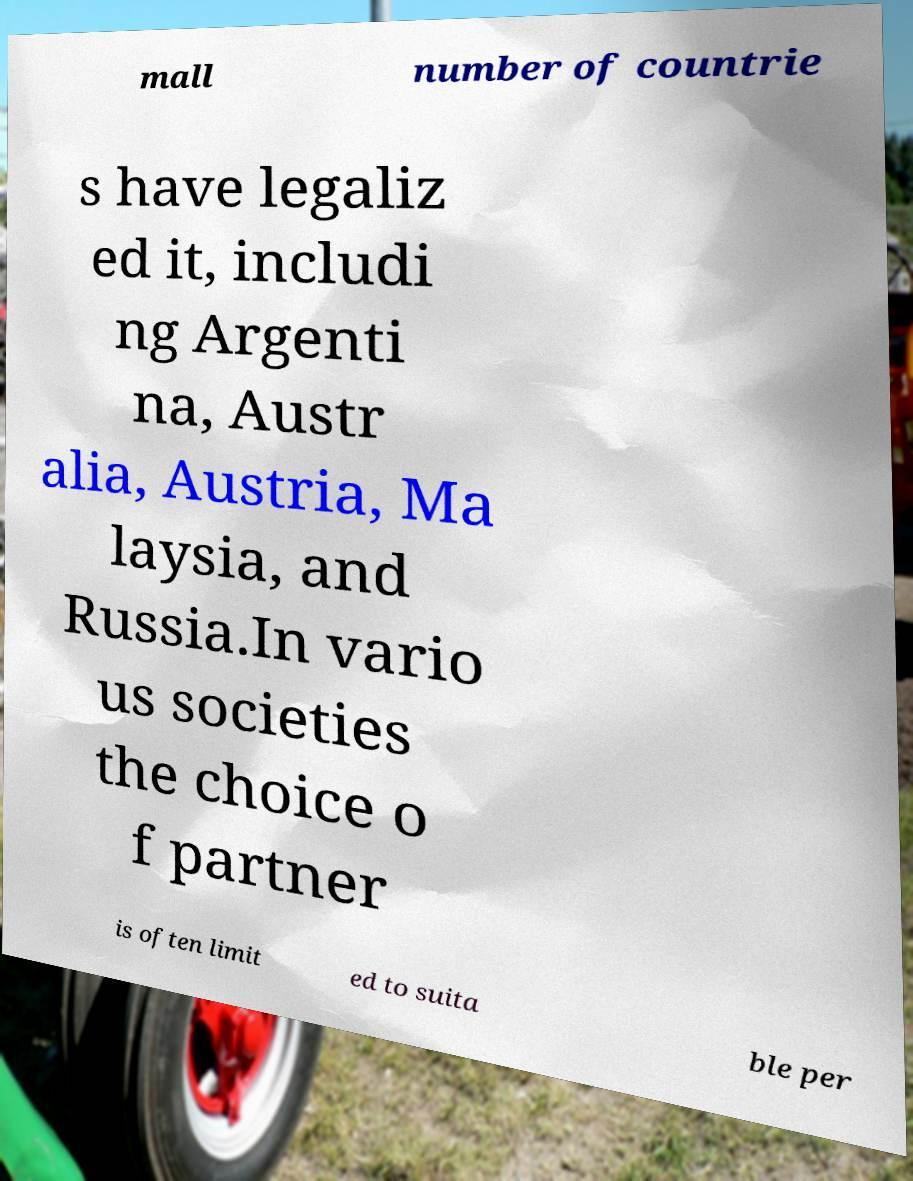Can you accurately transcribe the text from the provided image for me? mall number of countrie s have legaliz ed it, includi ng Argenti na, Austr alia, Austria, Ma laysia, and Russia.In vario us societies the choice o f partner is often limit ed to suita ble per 